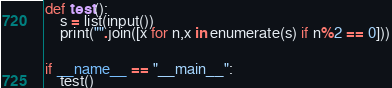Convert code to text. <code><loc_0><loc_0><loc_500><loc_500><_Python_>def test():
    s = list(input())
    print("".join([x for n,x in enumerate(s) if n%2 == 0]))


if __name__ == "__main__":
    test()
</code> 